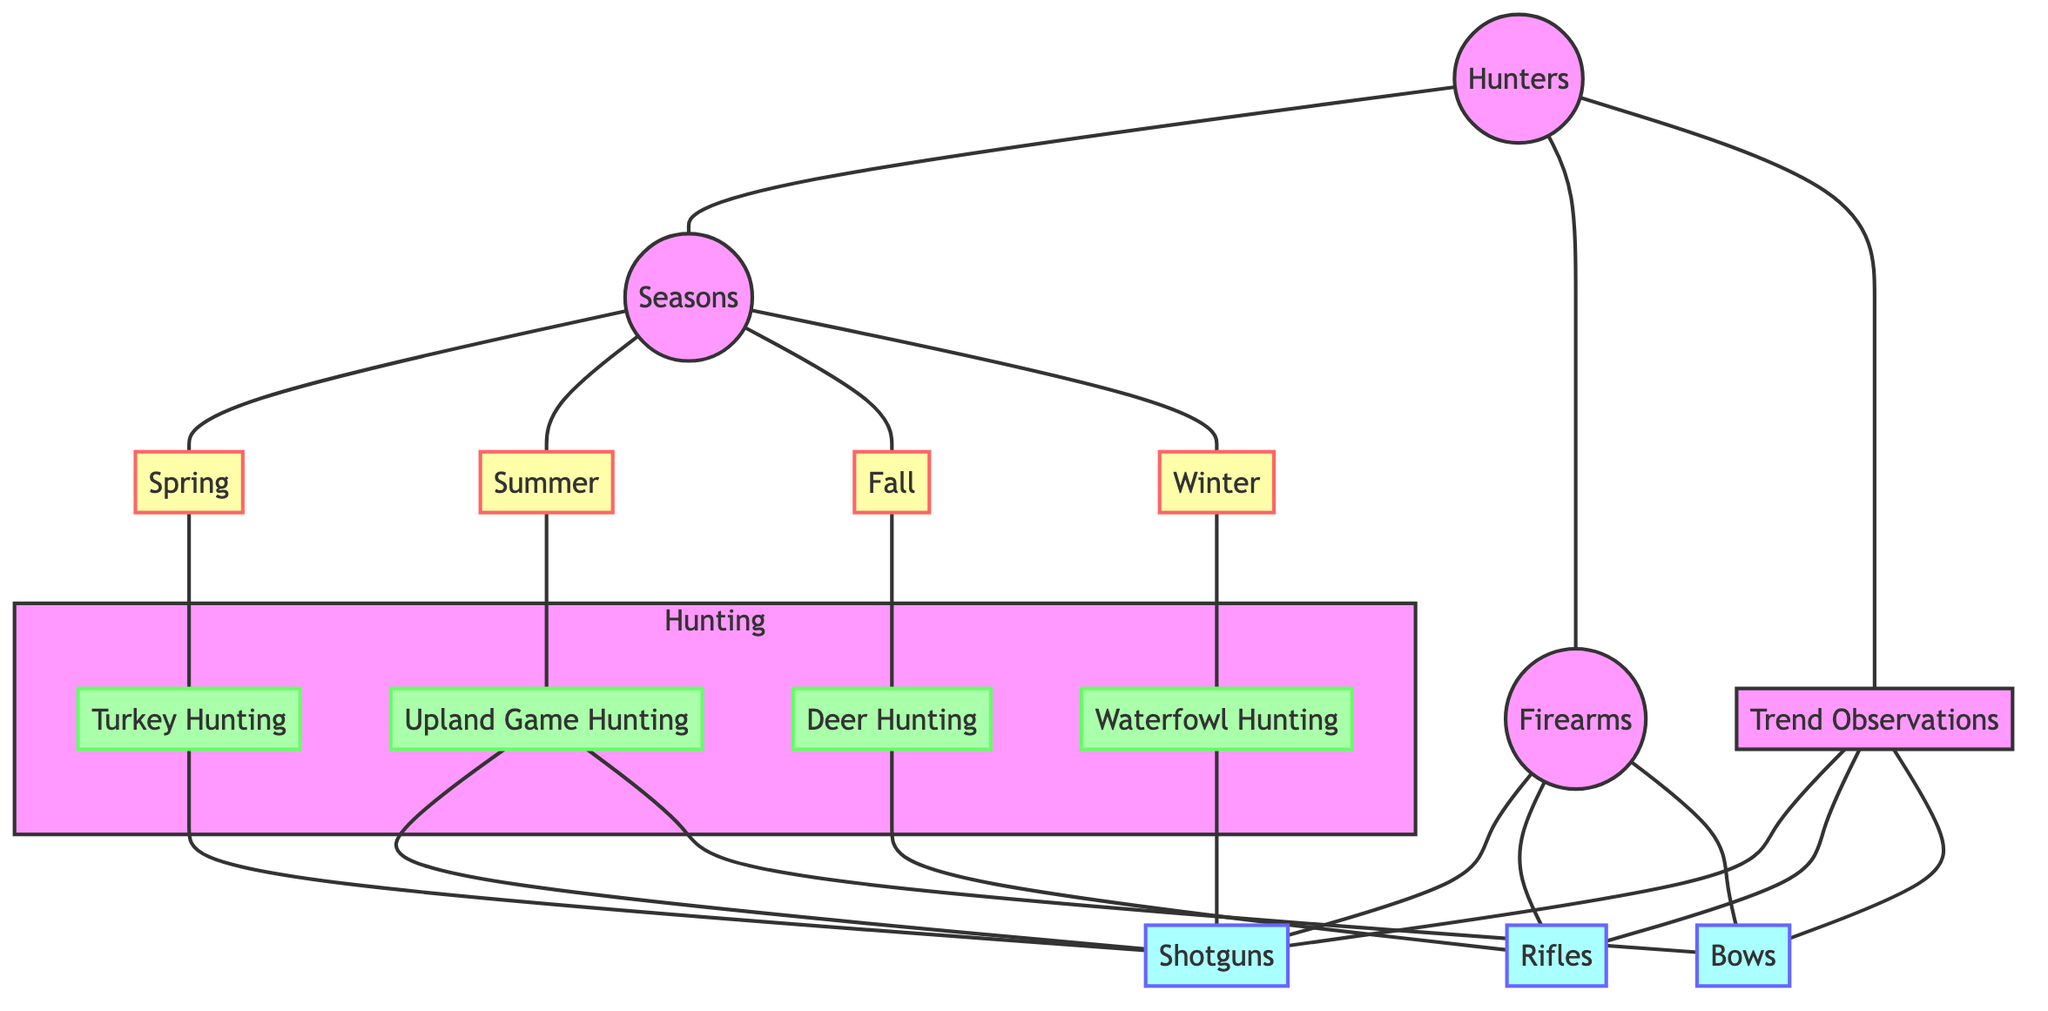What nodes are connected to Hunters? The nodes directly connected to "Hunters" are "Seasons," "Firearms," and "Trend Observations." These connections indicate the relationships and relevance of hunters to the different aspects of seasonality, firearm types, and observations of trends among hunters.
Answer: Seasons, Firearms, Trend Observations What hunting type is associated with Spring? The diagram indicates that "Turkey Hunting" is the type of hunting associated with "Spring." This connection shows that during the spring season, hunters typically engage in turkey hunting.
Answer: Turkey Hunting How many seasons are represented in the diagram? The diagram shows four seasons: "Spring," "Summer," "Fall," and "Winter." Counting these nodes reveals the number of different seasons relevant to hunting preferences.
Answer: 4 Which firearm type is commonly used for Deer Hunting? Based on the diagram, "Rifles" are the firearm type associated with "Deer Hunting," indicating that hunters typically use rifles when hunting deer in the fall season.
Answer: Rifles What is the connection between Upland Game Hunting and firearms? The connection indicates that "Upland Game Hunting" is associated with both "Shotguns" and "Bows." This means that hunters can use either of these firearm types when hunting upland game, reflecting the versatility in hunting approaches.
Answer: Shotguns, Bows How many edges connect Seasons and Firearms? There are a total of five edges connecting "Seasons" to specific types of hunting, which in turn lead to the associated firearms, as follows: "Spring" leads to "Turkey Hunting" and "Shotguns"; "Fall" leads to "Deer Hunting" and "Rifles"; "Winter" leads to "Waterfowl Hunting" and "Shotguns"; "Summer" connects to "Upland Game Hunting," which links to both "Shotguns" and "Bows." Thus, several indirect connections illustrate preferences.
Answer: 5 What trends were noted among hunters in regard to firearms? The diagram indicates notable trends for all mentioned firearm types: "Shotguns," "Rifles," and "Bows." These trends reflect the prevailing preferences among hunters as identified in the trend observations section of the diagram.
Answer: Shotguns, Rifles, Bows What seasonal preference is most likely associated with Shotguns? Based on the connections in the diagram, "Shotguns" are associated with "Turkey Hunting" in Spring, "Waterfowl Hunting" in Winter, and "Upland Game Hunting" in Summer. This suggests that shotguns are versatile across multiple seasons but specifically highlighted for these specific types of hunting.
Answer: Turkey Hunting, Waterfowl Hunting, Upland Game Hunting 